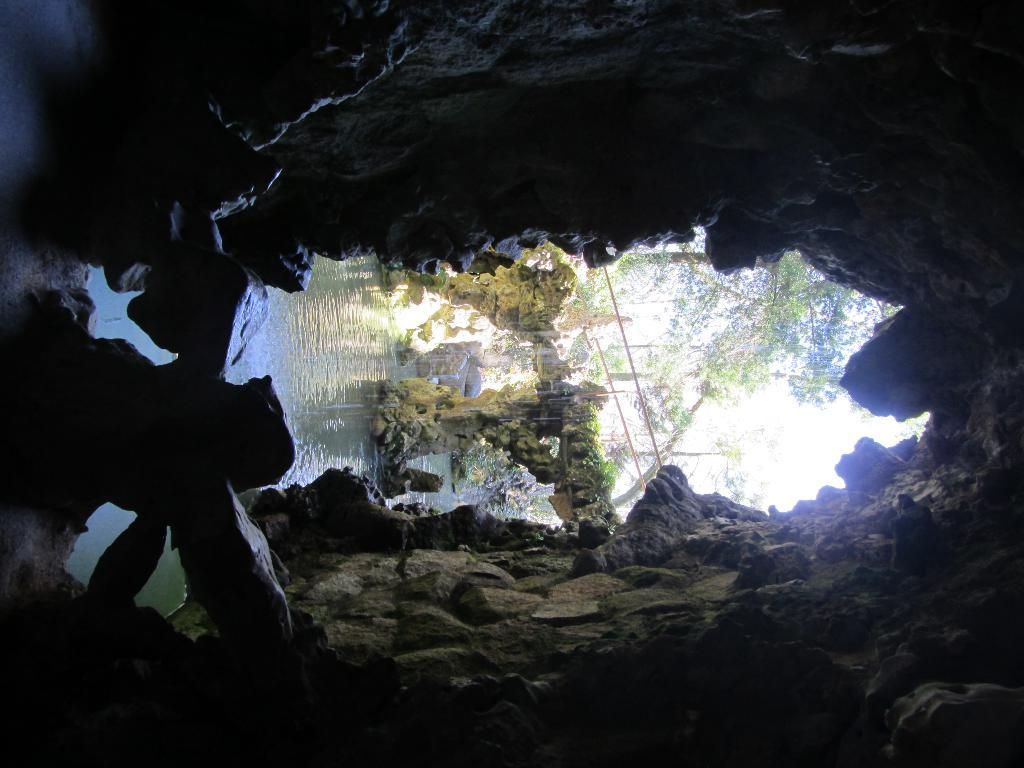What type of natural formation is present in the image? There is a cave in the image. What other geological features can be seen in the image? There are rocks in the image. What is the water source in the image? There is water in the image. Are there any man-made structures visible in the image? Yes, there are wires and a bridge in the image. What type of vegetation is present in the image? There are trees in the image. What part of the natural environment is visible in the image? The sky is visible in the image. What type of skin condition is visible on the manager's face in the image? There is no manager or skin condition present in the image. What type of trip can be taken by crossing the bridge in the image? The image does not provide information about a trip or the purpose of crossing the bridge. 